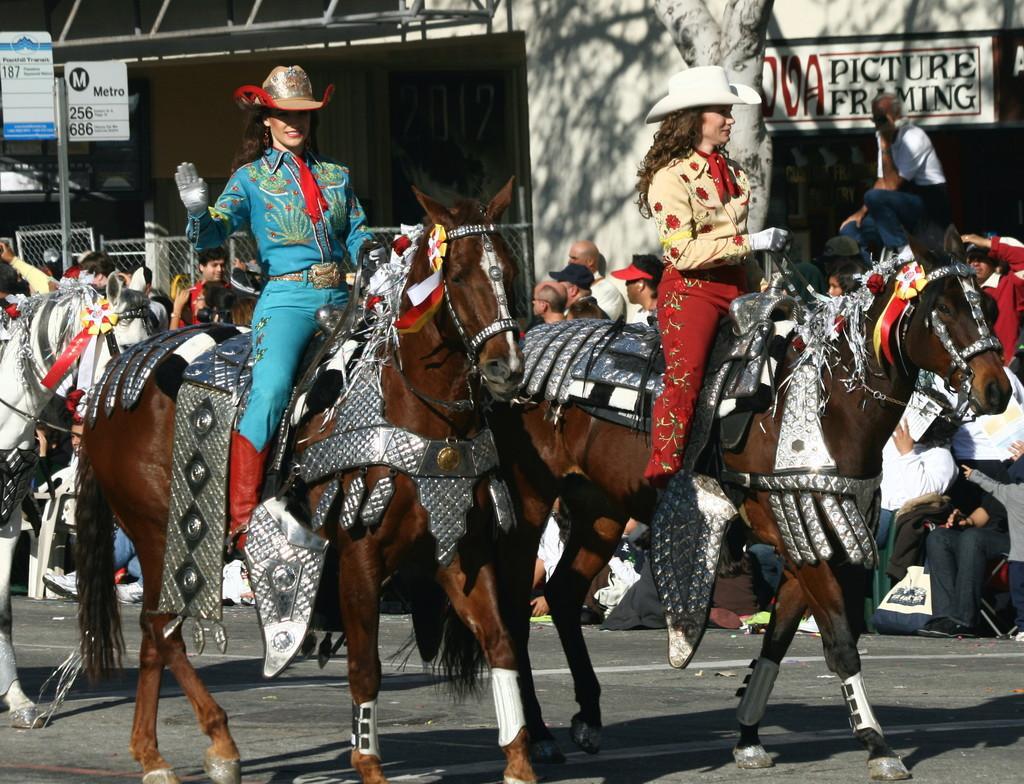Describe this image in one or two sentences. This is a picture taken in the out door, there are two women's riding the horse and the other people were watching them and there is a sign board and the two women were wearing a hat. 